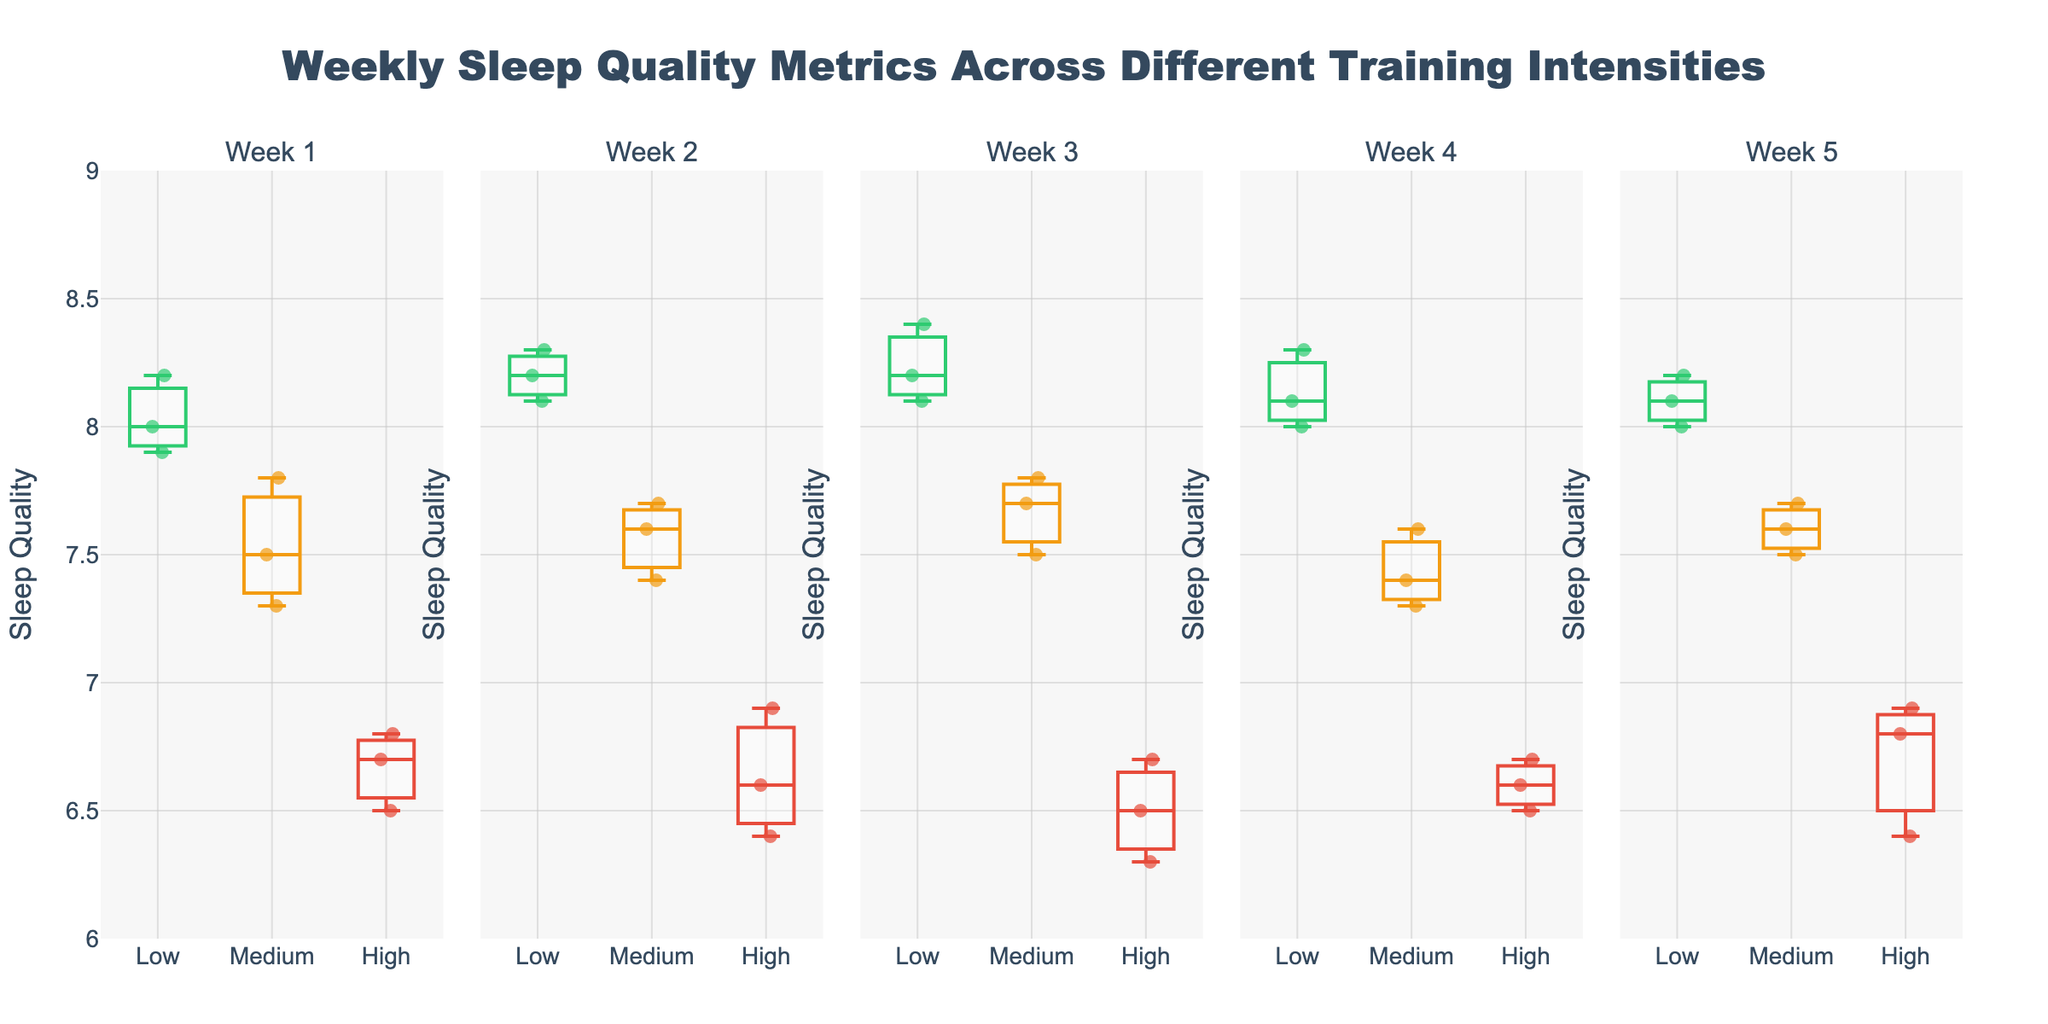What is the title of the figure? The title is usually displayed prominently at the top of the figure. By looking at this area, you can see the title written as "Weekly Sleep Quality Metrics Across Different Training Intensities".
Answer: Weekly Sleep Quality Metrics Across Different Training Intensities What is the range of the y-axis for sleep quality? Look at the y-axis on the left side of the figure. The range is specified from 6 to 9, with tick marks every 0.5 units.
Answer: 6 to 9 How does the median sleep quality compare between low and high training intensities in Week 1? In each box plot, the median is marked by a line within the box. For Week 1, compare the position of these lines for low and high training intensities. The median for low intensity is around 8.0, while for high intensity, it is around 6.7.
Answer: The median sleep quality is higher for low intensity In which week does the high training intensity show the lowest median sleep quality? Compare the position of the median lines in the box plots for high training intensity across all weeks. The lowest median is in Week 3, where it appears to be around 6.3.
Answer: Week 3 What's the interquartile range for medium training intensity in Week 2? The interquartile range (IQR) is the difference between the upper and lower quartiles (the top and bottom edges of the box). For medium intensity in Week 2, approximate these values as around 7.7 (upper) and 7.4 (lower). IQR = 7.7 - 7.4.
Answer: 0.3 Which training intensity shows the most consistent sleep quality across all weeks? Consistency can be evaluated by the spread of data points and the length of whiskers in the box plots. The box plots for low intensity have the smallest spread across all weeks.
Answer: Low intensity Which training intensity has the widest range of sleep quality in Week 4? Look at the length of the whiskers (the lines extending from the box's upper and lower boundaries). For Week 4, the high intensity has the widest range, as the whiskers stretch from about 6.5 to 8.0.
Answer: High intensity How does sleep quality generally vary with training intensity across all weeks? By observing each week's box plots, it is apparent that as training intensity increases (from Low to High), the median and overall sleep quality tends to decrease.
Answer: Sleep quality decreases with higher training intensity Are there any outliers in the sleep quality data for any of the weeks? Outliers are often represented by individual points outside the whiskers of the box plot. In this figure, there are no points lying outside the whiskers.
Answer: No Which week shows the highest median sleep quality for low training intensity? Compare the position of the median lines in the box plots for low training intensity across all weeks. The highest median is in Week 3, where it appears just above 8.3.
Answer: Week 3 